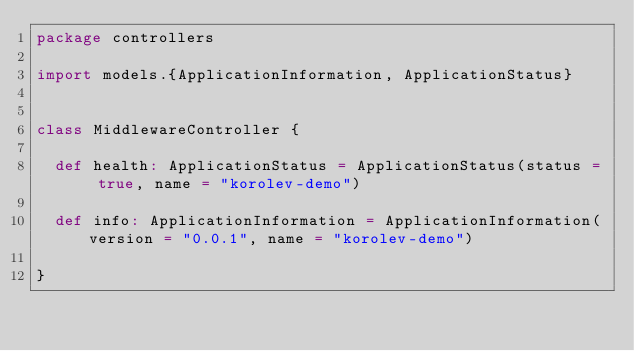<code> <loc_0><loc_0><loc_500><loc_500><_Scala_>package controllers

import models.{ApplicationInformation, ApplicationStatus}


class MiddlewareController {

  def health: ApplicationStatus = ApplicationStatus(status = true, name = "korolev-demo")

  def info: ApplicationInformation = ApplicationInformation(version = "0.0.1", name = "korolev-demo")

}
</code> 